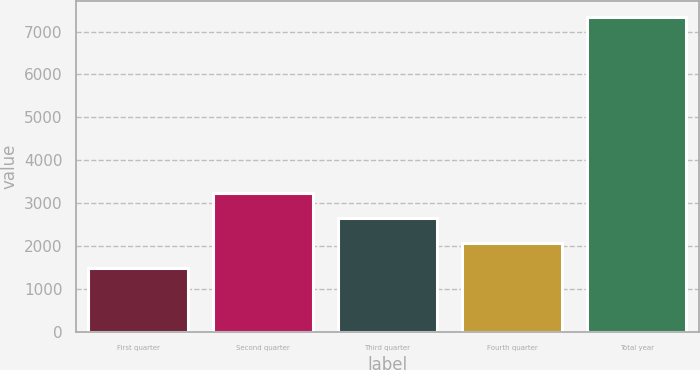<chart> <loc_0><loc_0><loc_500><loc_500><bar_chart><fcel>First quarter<fcel>Second quarter<fcel>Third quarter<fcel>Fourth quarter<fcel>Total year<nl><fcel>1486.8<fcel>3245.4<fcel>2659.2<fcel>2073<fcel>7348.8<nl></chart> 